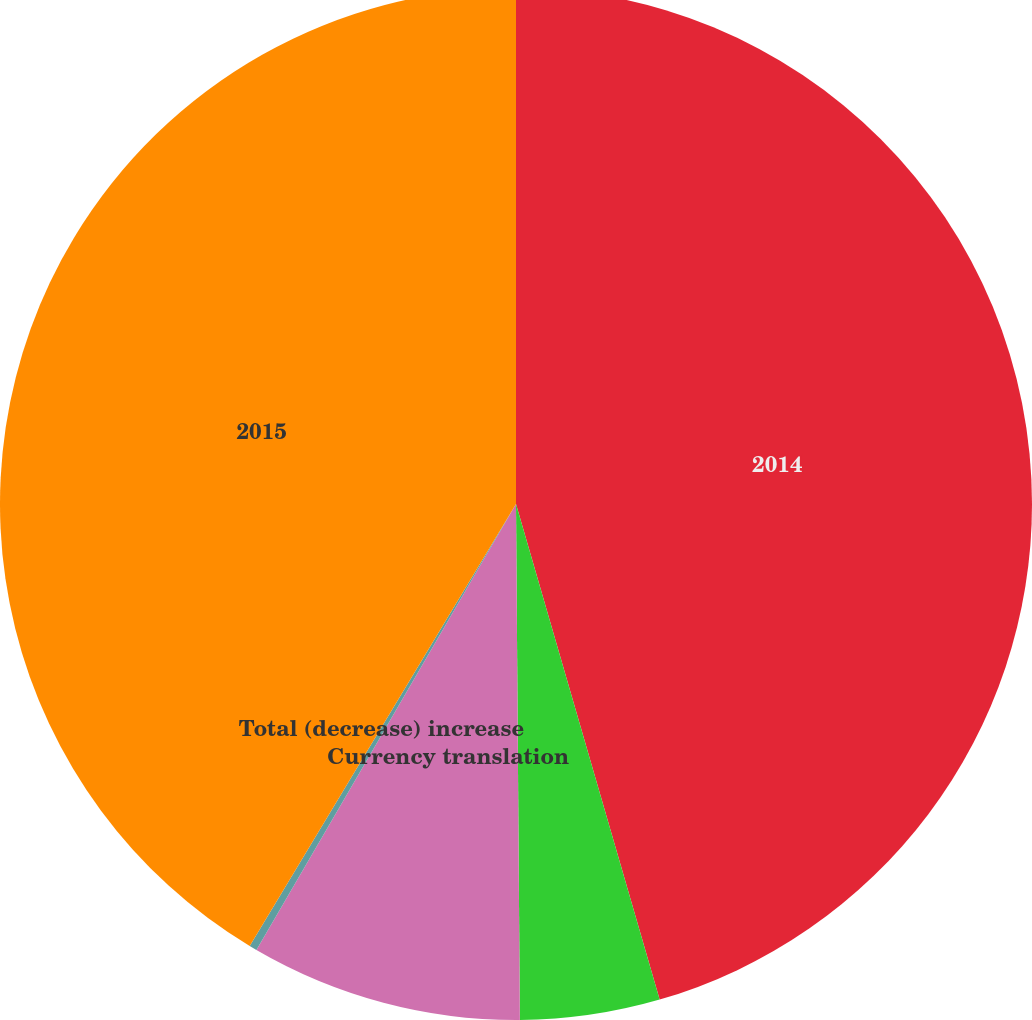Convert chart. <chart><loc_0><loc_0><loc_500><loc_500><pie_chart><fcel>2014<fcel>Aftermarket parts volume<fcel>Currency translation<fcel>Total (decrease) increase<fcel>2015<nl><fcel>45.51%<fcel>4.37%<fcel>8.51%<fcel>0.24%<fcel>41.37%<nl></chart> 